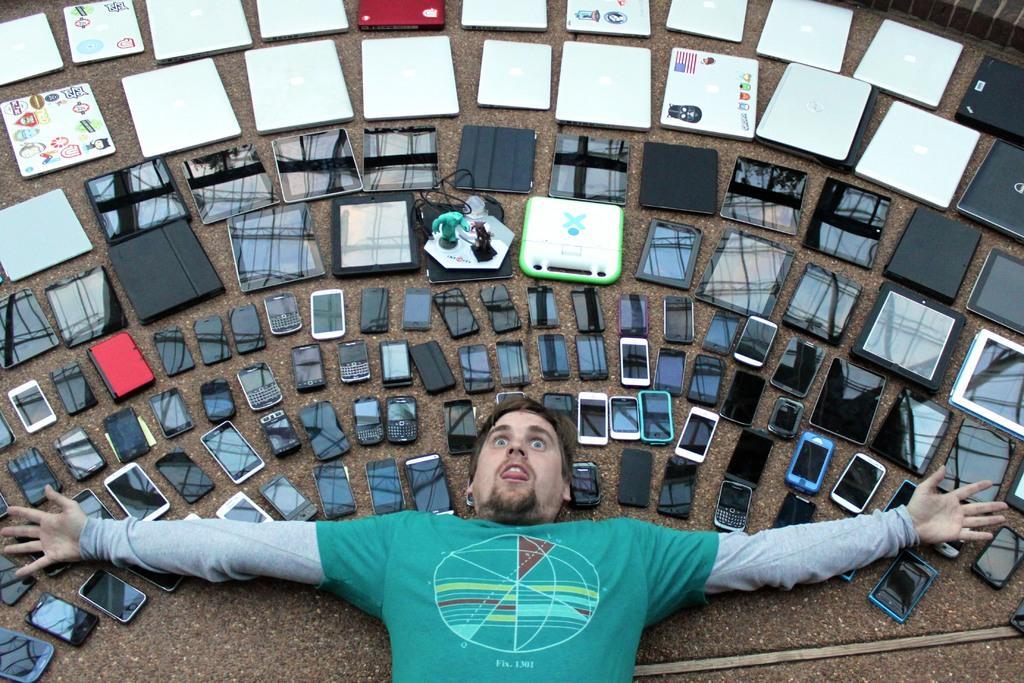In one or two sentences, can you explain what this image depicts? In this picture we can see a man is laying on the floor and on the floor there are different kinds of mobiles, tablets and laptops. 